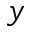<formula> <loc_0><loc_0><loc_500><loc_500>y</formula> 